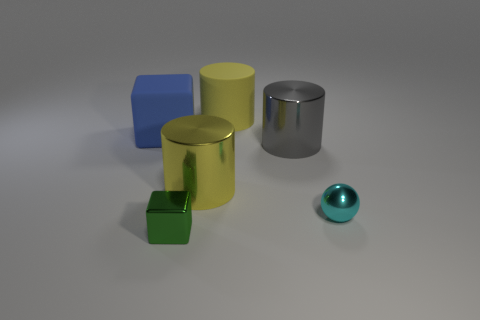How many yellow cylinders must be subtracted to get 1 yellow cylinders? 1 Subtract all red cubes. How many yellow cylinders are left? 2 Add 2 large blue matte cubes. How many objects exist? 8 Subtract 0 purple spheres. How many objects are left? 6 Subtract all blocks. How many objects are left? 4 Subtract all cyan rubber spheres. Subtract all small green blocks. How many objects are left? 5 Add 4 large objects. How many large objects are left? 8 Add 6 tiny shiny things. How many tiny shiny things exist? 8 